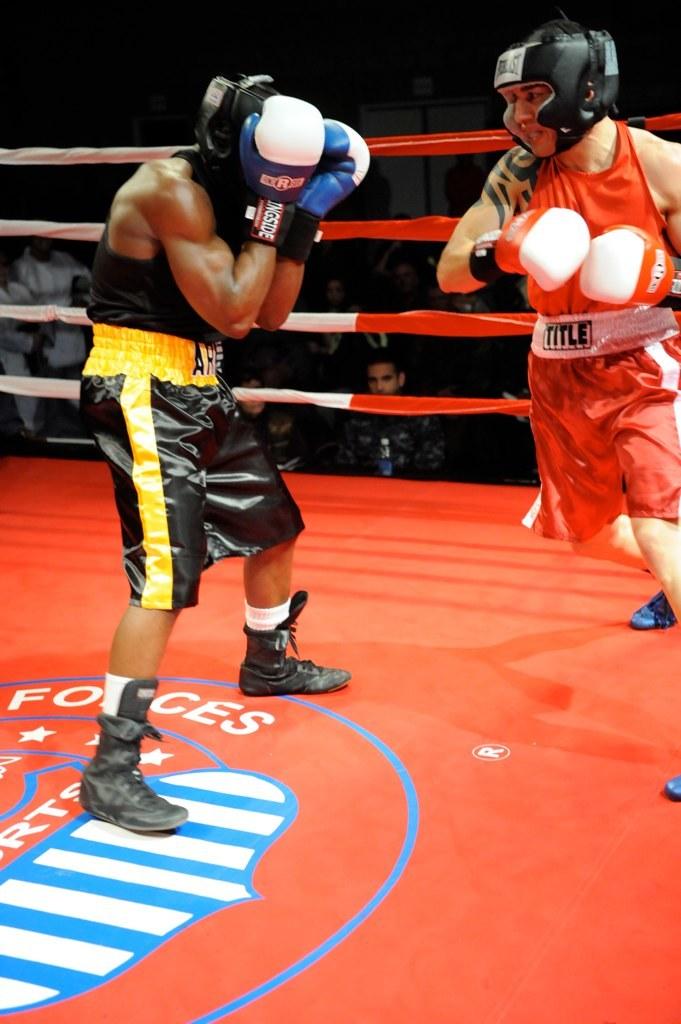What does the mat say?
Provide a short and direct response. Forces. What is written on the white belt?
Offer a very short reply. Title. 